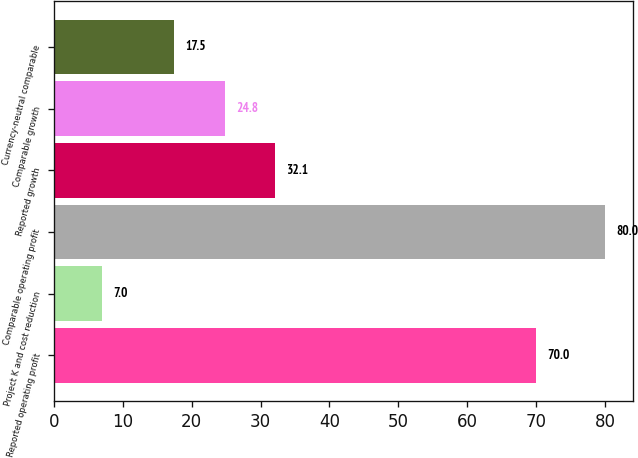Convert chart. <chart><loc_0><loc_0><loc_500><loc_500><bar_chart><fcel>Reported operating profit<fcel>Project K and cost reduction<fcel>Comparable operating profit<fcel>Reported growth<fcel>Comparable growth<fcel>Currency-neutral comparable<nl><fcel>70<fcel>7<fcel>80<fcel>32.1<fcel>24.8<fcel>17.5<nl></chart> 